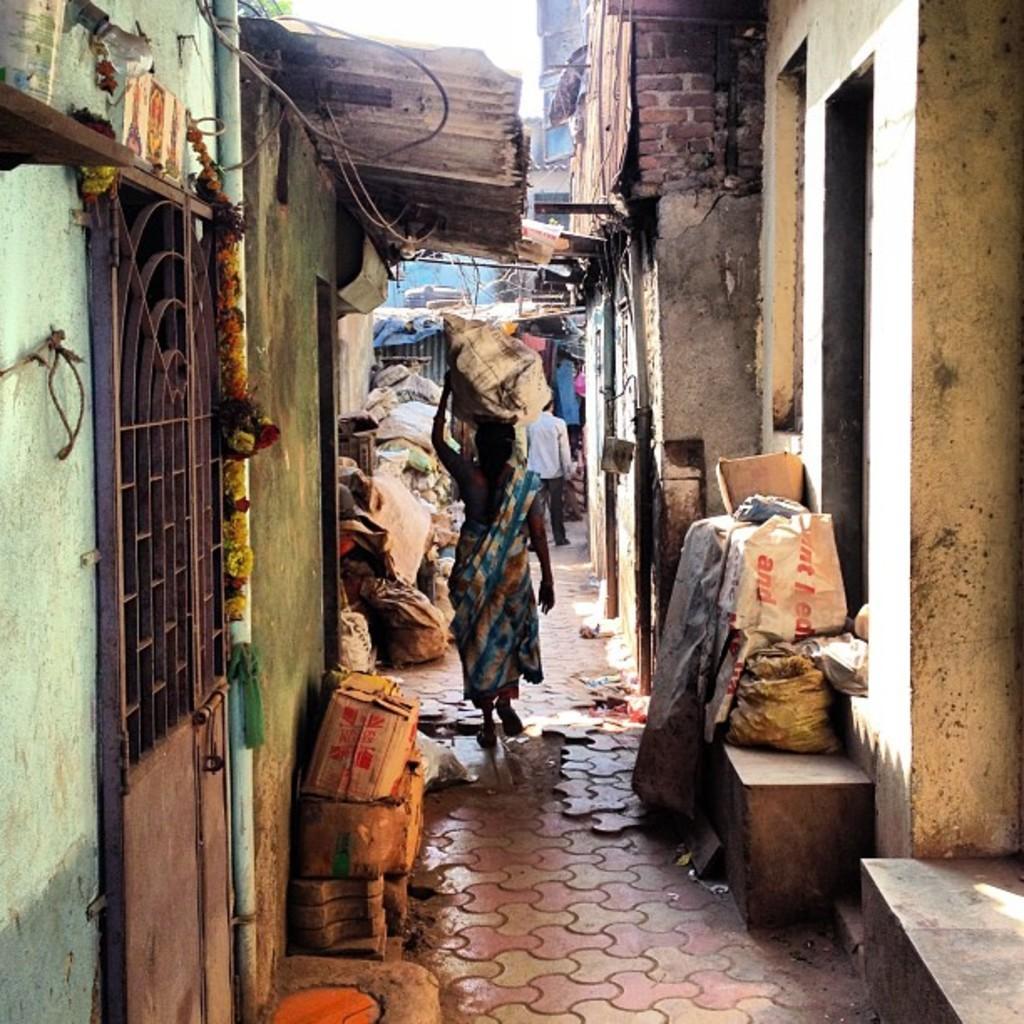How would you summarize this image in a sentence or two? In this picture I can see people are walking on the path, sides we can see houses and few objects are placed. 